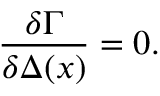Convert formula to latex. <formula><loc_0><loc_0><loc_500><loc_500>\frac { \delta \Gamma } { \delta \Delta ( x ) } = 0 .</formula> 